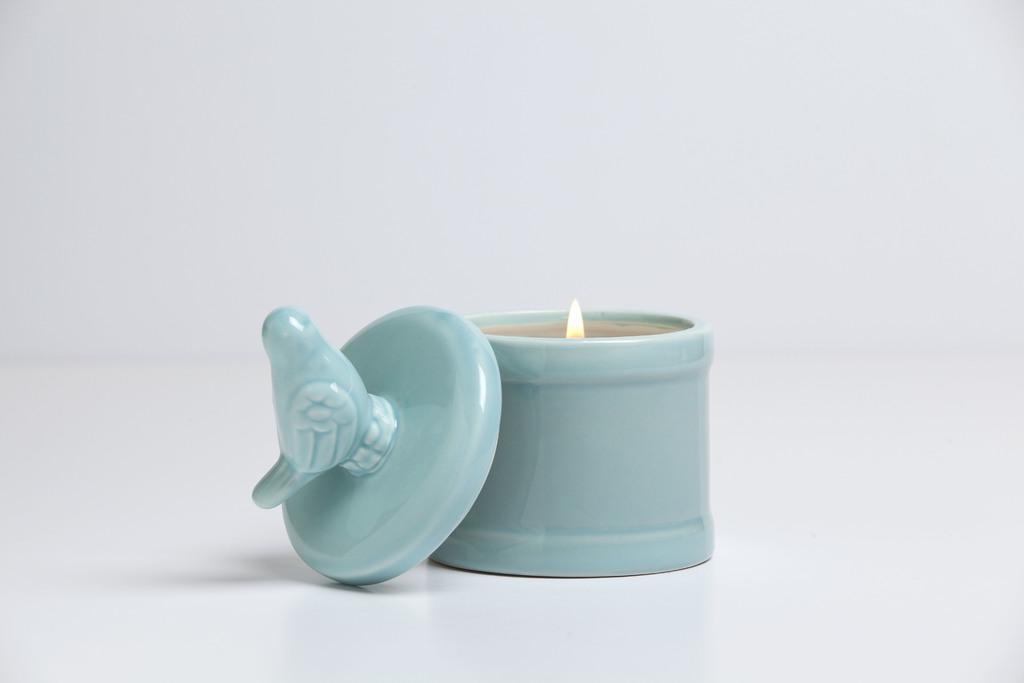Can you describe this image briefly? In this image there is a ceramic candle holder. There is a flame above it. Beside it there is a lid of the holder. On the lid there is a sculpture of a bird. The background is white. 